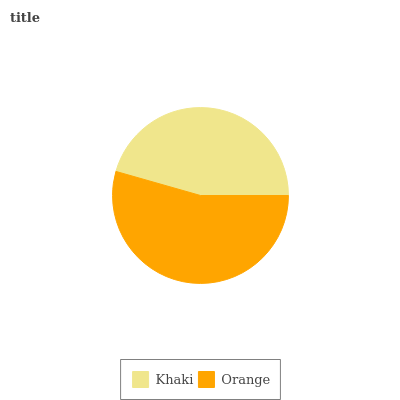Is Khaki the minimum?
Answer yes or no. Yes. Is Orange the maximum?
Answer yes or no. Yes. Is Orange the minimum?
Answer yes or no. No. Is Orange greater than Khaki?
Answer yes or no. Yes. Is Khaki less than Orange?
Answer yes or no. Yes. Is Khaki greater than Orange?
Answer yes or no. No. Is Orange less than Khaki?
Answer yes or no. No. Is Orange the high median?
Answer yes or no. Yes. Is Khaki the low median?
Answer yes or no. Yes. Is Khaki the high median?
Answer yes or no. No. Is Orange the low median?
Answer yes or no. No. 